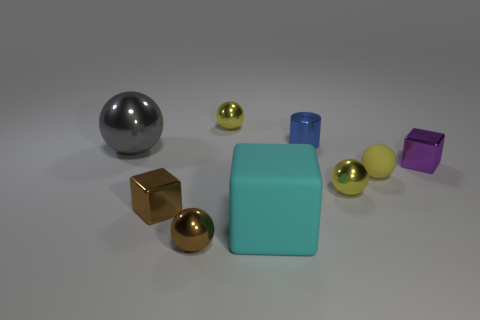Subtract all yellow spheres. How many were subtracted if there are1yellow spheres left? 2 Subtract all yellow cubes. How many yellow spheres are left? 3 Subtract 1 spheres. How many spheres are left? 4 Subtract all brown balls. How many balls are left? 4 Subtract all yellow matte balls. How many balls are left? 4 Subtract all purple spheres. Subtract all yellow blocks. How many spheres are left? 5 Add 1 gray metal cylinders. How many objects exist? 10 Subtract all spheres. How many objects are left? 4 Add 7 small blue cylinders. How many small blue cylinders exist? 8 Subtract 0 blue spheres. How many objects are left? 9 